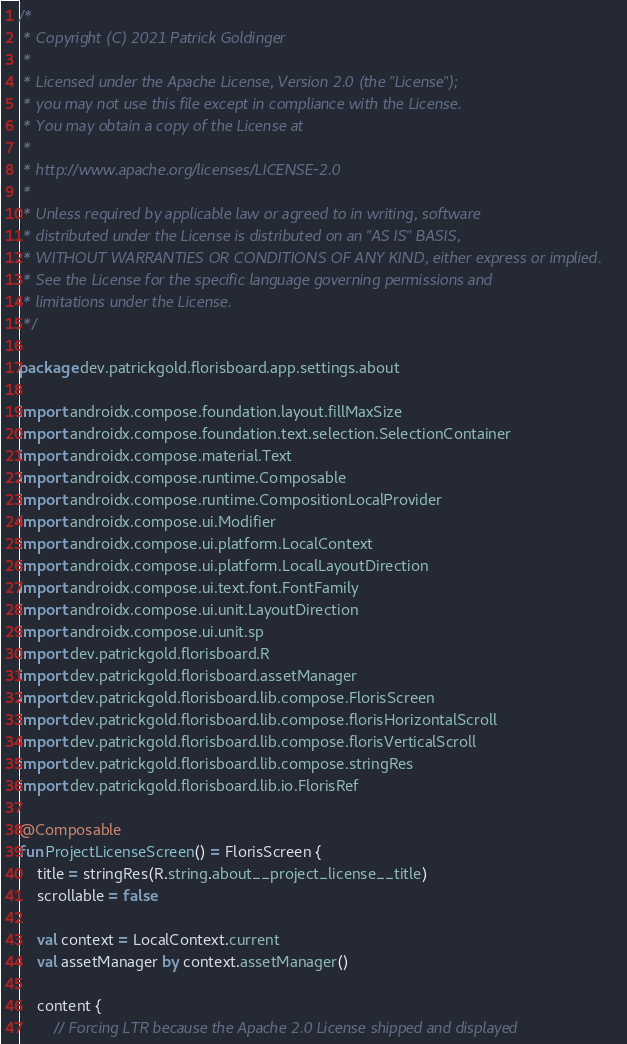<code> <loc_0><loc_0><loc_500><loc_500><_Kotlin_>/*
 * Copyright (C) 2021 Patrick Goldinger
 *
 * Licensed under the Apache License, Version 2.0 (the "License");
 * you may not use this file except in compliance with the License.
 * You may obtain a copy of the License at
 *
 * http://www.apache.org/licenses/LICENSE-2.0
 *
 * Unless required by applicable law or agreed to in writing, software
 * distributed under the License is distributed on an "AS IS" BASIS,
 * WITHOUT WARRANTIES OR CONDITIONS OF ANY KIND, either express or implied.
 * See the License for the specific language governing permissions and
 * limitations under the License.
 */

package dev.patrickgold.florisboard.app.settings.about

import androidx.compose.foundation.layout.fillMaxSize
import androidx.compose.foundation.text.selection.SelectionContainer
import androidx.compose.material.Text
import androidx.compose.runtime.Composable
import androidx.compose.runtime.CompositionLocalProvider
import androidx.compose.ui.Modifier
import androidx.compose.ui.platform.LocalContext
import androidx.compose.ui.platform.LocalLayoutDirection
import androidx.compose.ui.text.font.FontFamily
import androidx.compose.ui.unit.LayoutDirection
import androidx.compose.ui.unit.sp
import dev.patrickgold.florisboard.R
import dev.patrickgold.florisboard.assetManager
import dev.patrickgold.florisboard.lib.compose.FlorisScreen
import dev.patrickgold.florisboard.lib.compose.florisHorizontalScroll
import dev.patrickgold.florisboard.lib.compose.florisVerticalScroll
import dev.patrickgold.florisboard.lib.compose.stringRes
import dev.patrickgold.florisboard.lib.io.FlorisRef

@Composable
fun ProjectLicenseScreen() = FlorisScreen {
    title = stringRes(R.string.about__project_license__title)
    scrollable = false

    val context = LocalContext.current
    val assetManager by context.assetManager()

    content {
        // Forcing LTR because the Apache 2.0 License shipped and displayed</code> 